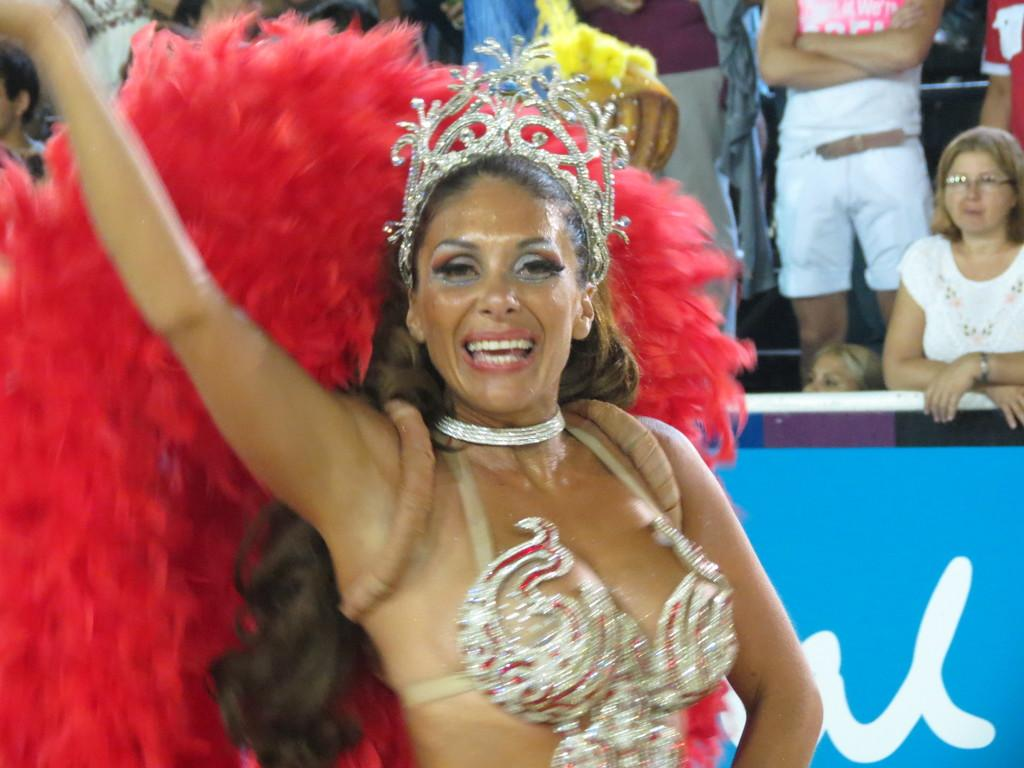What is the lady in the image wearing? There is a lady wearing a costume in the image. Can you describe the background of the image? There are people standing in the background of the image. What is the blue object in the image? There is a blue color board with some text on it in the image. How many lizards can be seen sleeping on the lady's costume in the image? There are no lizards present in the image, and the lady is not sleeping on her costume. 